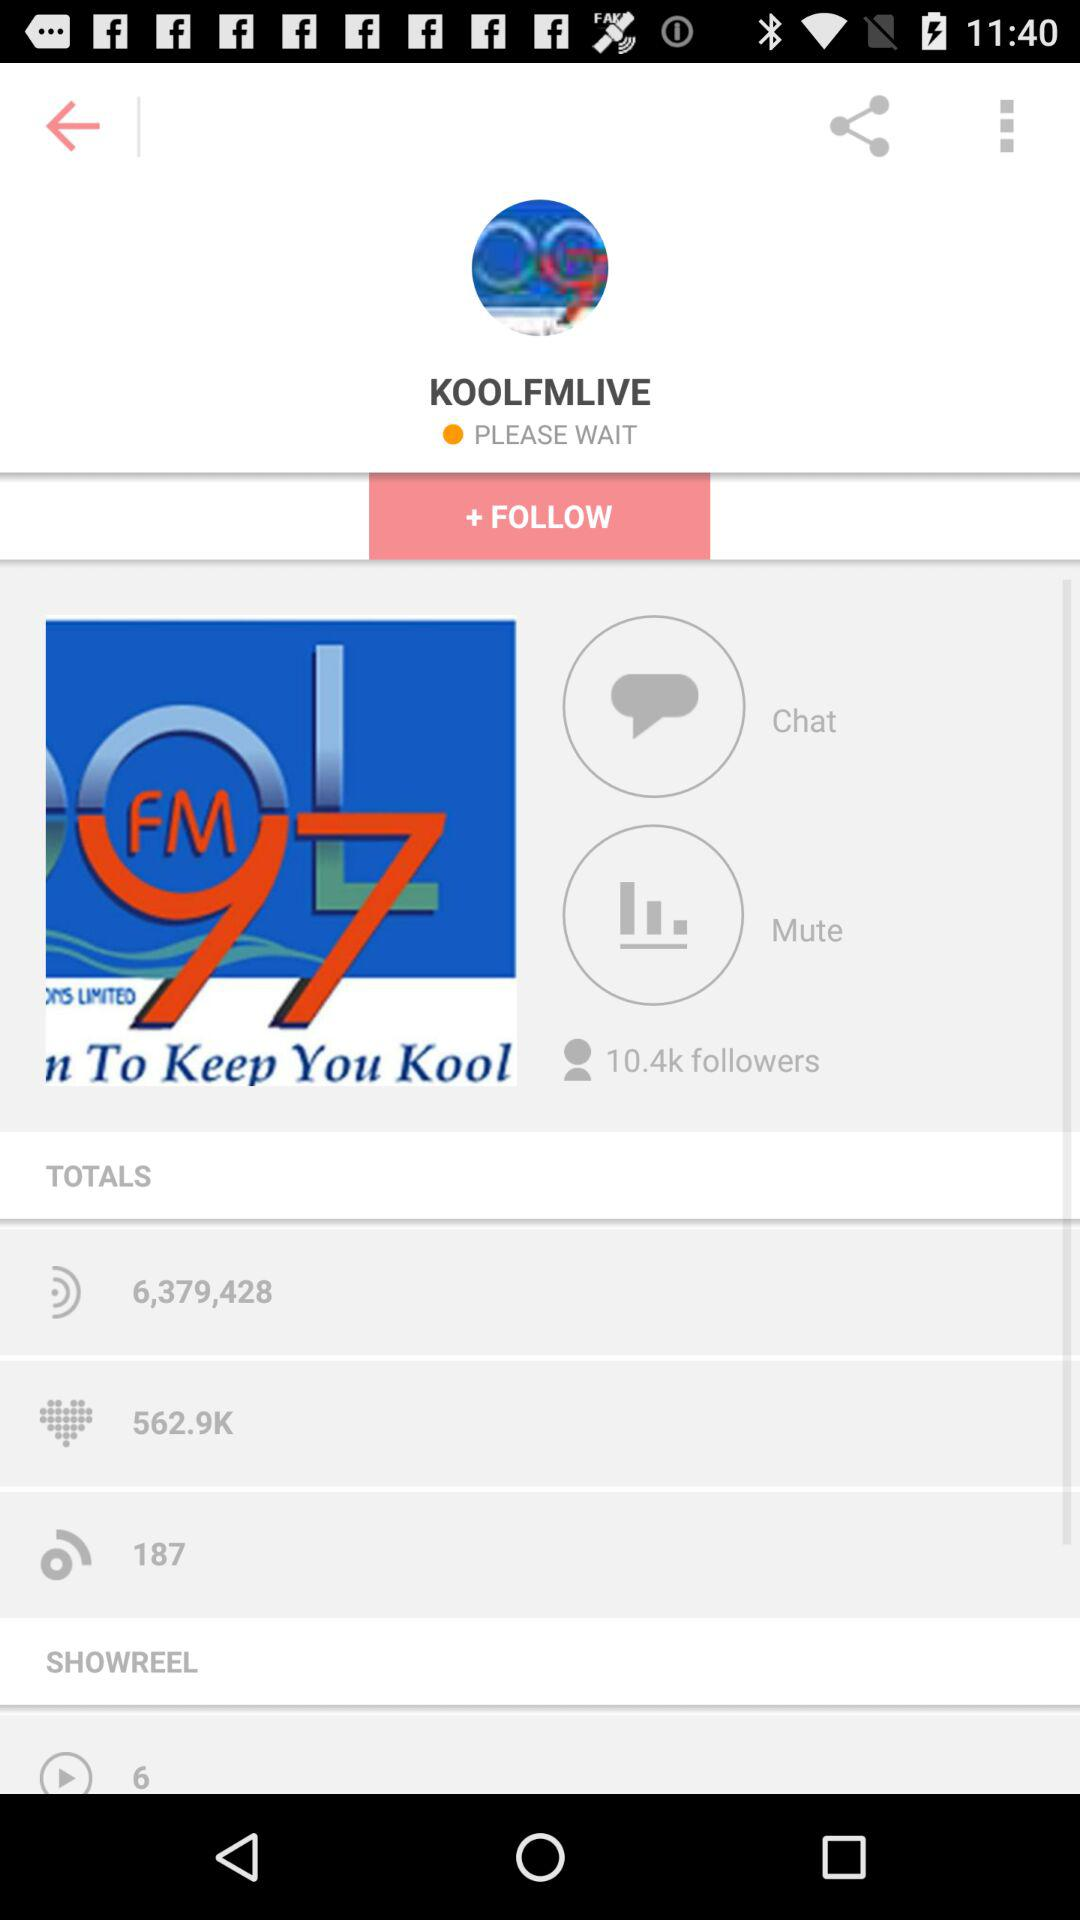What's the name of the account? The name of the account is "KOOLFMLIVE". 